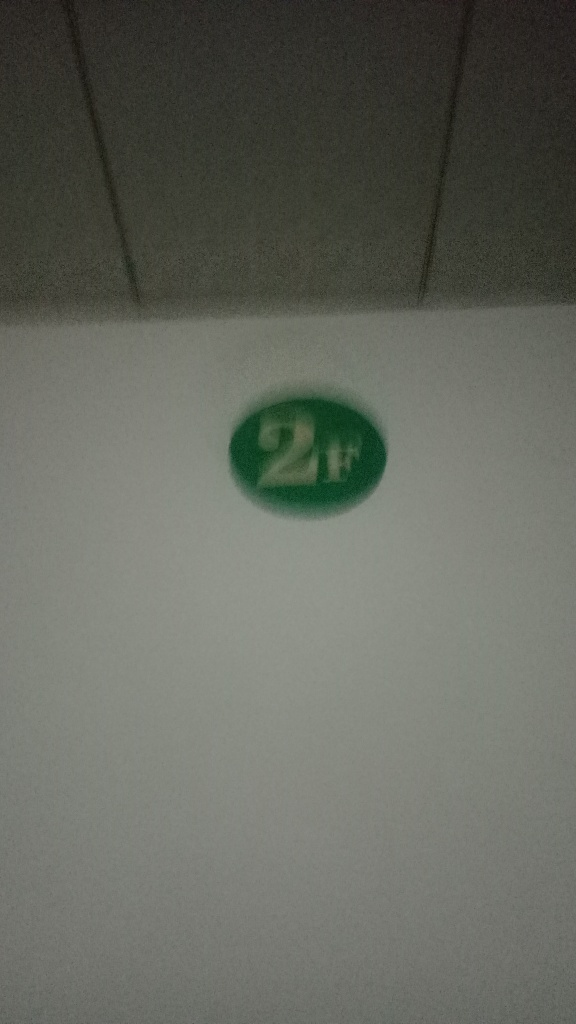How could this image be improved to convey a clearer message? Improving the image's clarity would involve taking the photo with better lighting, a steady hand or on a stable surface to avoid blurriness, and focusing on the object to make it the central point of attention. Additionally, providing some context within the frame could help convey the intended message or function of the '2H' mark more explicitly. 